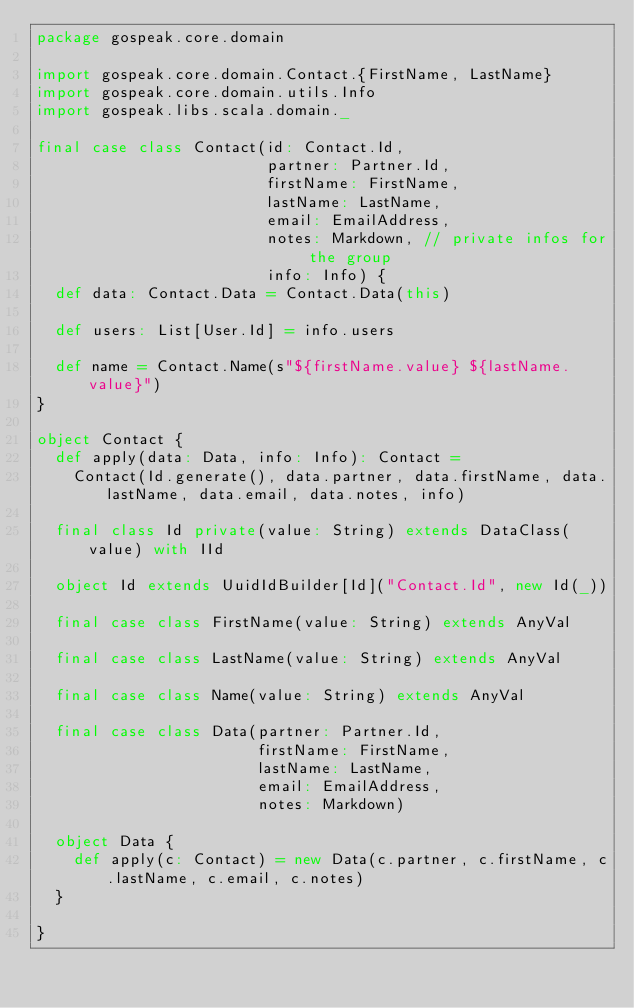Convert code to text. <code><loc_0><loc_0><loc_500><loc_500><_Scala_>package gospeak.core.domain

import gospeak.core.domain.Contact.{FirstName, LastName}
import gospeak.core.domain.utils.Info
import gospeak.libs.scala.domain._

final case class Contact(id: Contact.Id,
                         partner: Partner.Id,
                         firstName: FirstName,
                         lastName: LastName,
                         email: EmailAddress,
                         notes: Markdown, // private infos for the group
                         info: Info) {
  def data: Contact.Data = Contact.Data(this)

  def users: List[User.Id] = info.users

  def name = Contact.Name(s"${firstName.value} ${lastName.value}")
}

object Contact {
  def apply(data: Data, info: Info): Contact =
    Contact(Id.generate(), data.partner, data.firstName, data.lastName, data.email, data.notes, info)

  final class Id private(value: String) extends DataClass(value) with IId

  object Id extends UuidIdBuilder[Id]("Contact.Id", new Id(_))

  final case class FirstName(value: String) extends AnyVal

  final case class LastName(value: String) extends AnyVal

  final case class Name(value: String) extends AnyVal

  final case class Data(partner: Partner.Id,
                        firstName: FirstName,
                        lastName: LastName,
                        email: EmailAddress,
                        notes: Markdown)

  object Data {
    def apply(c: Contact) = new Data(c.partner, c.firstName, c.lastName, c.email, c.notes)
  }

}
</code> 